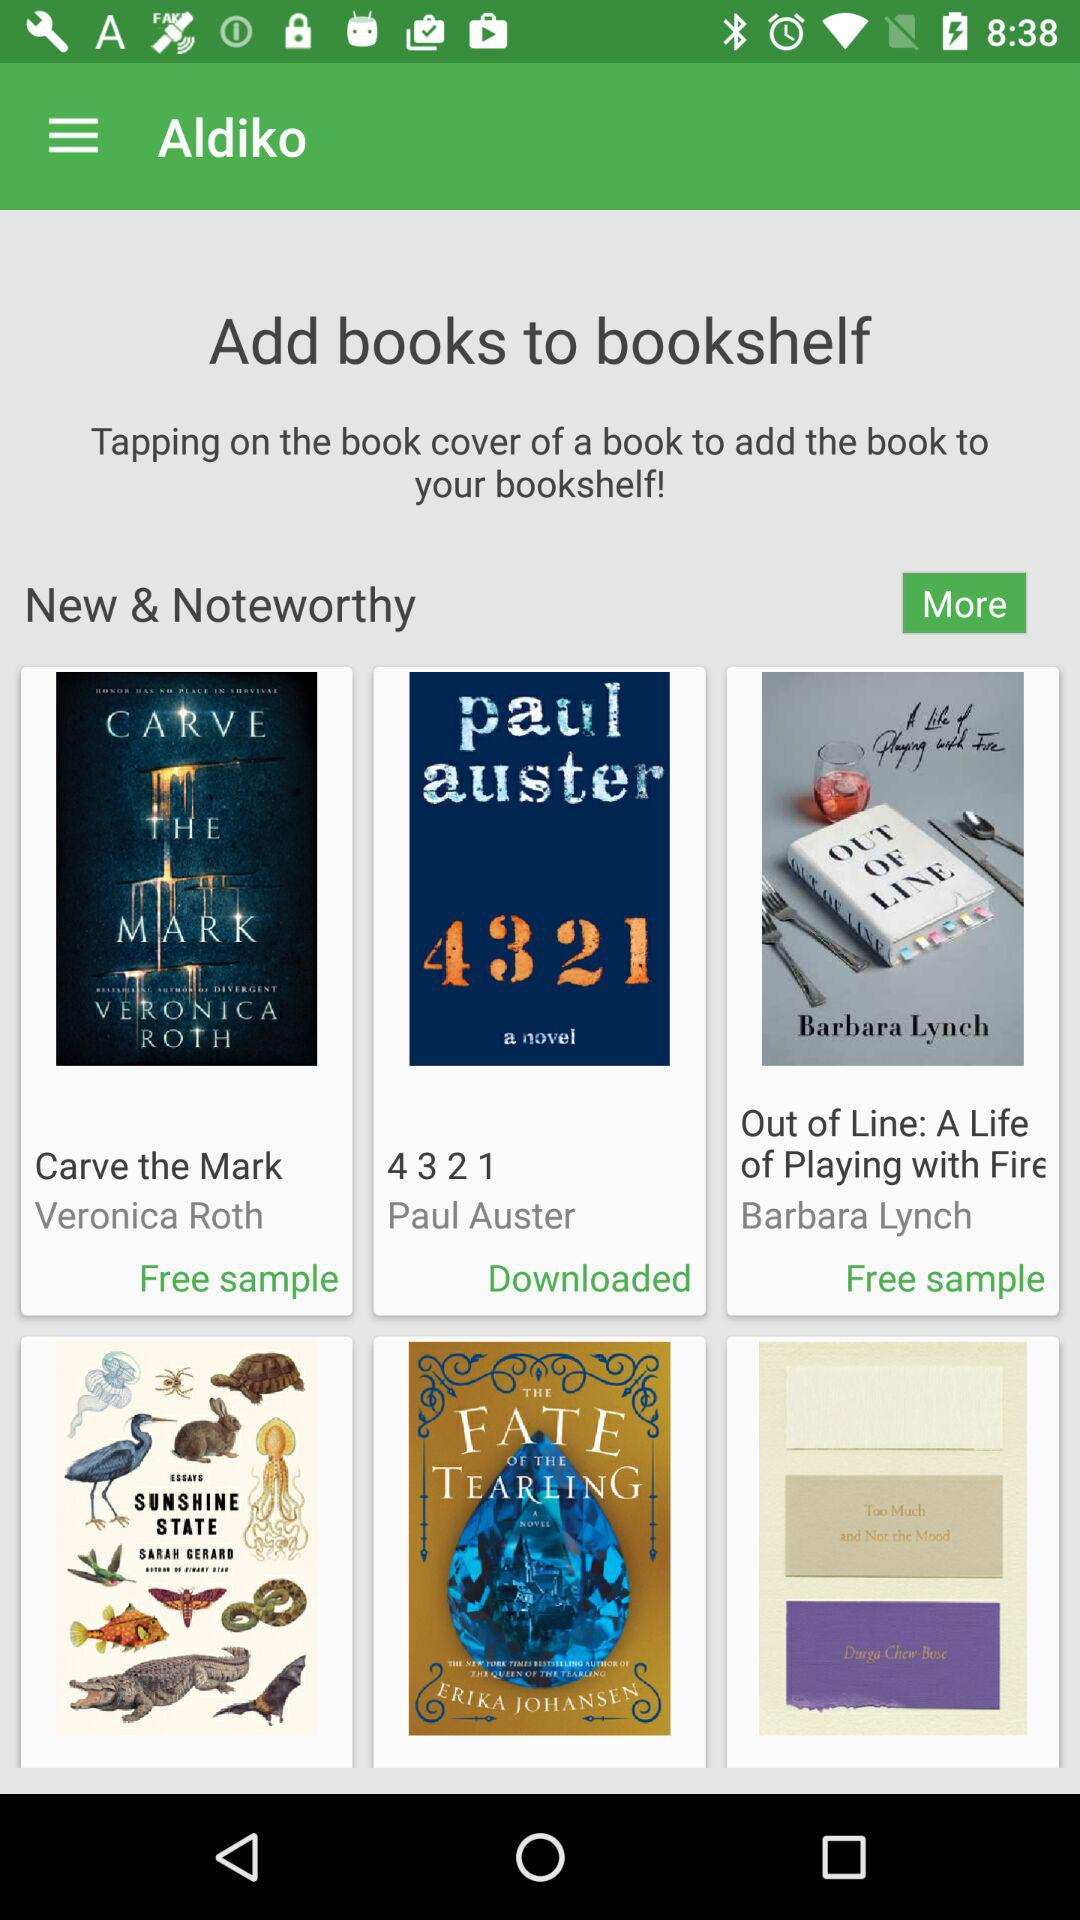Who wrote the book "4 3 2 1"? The book was written by "Paul Auster". 